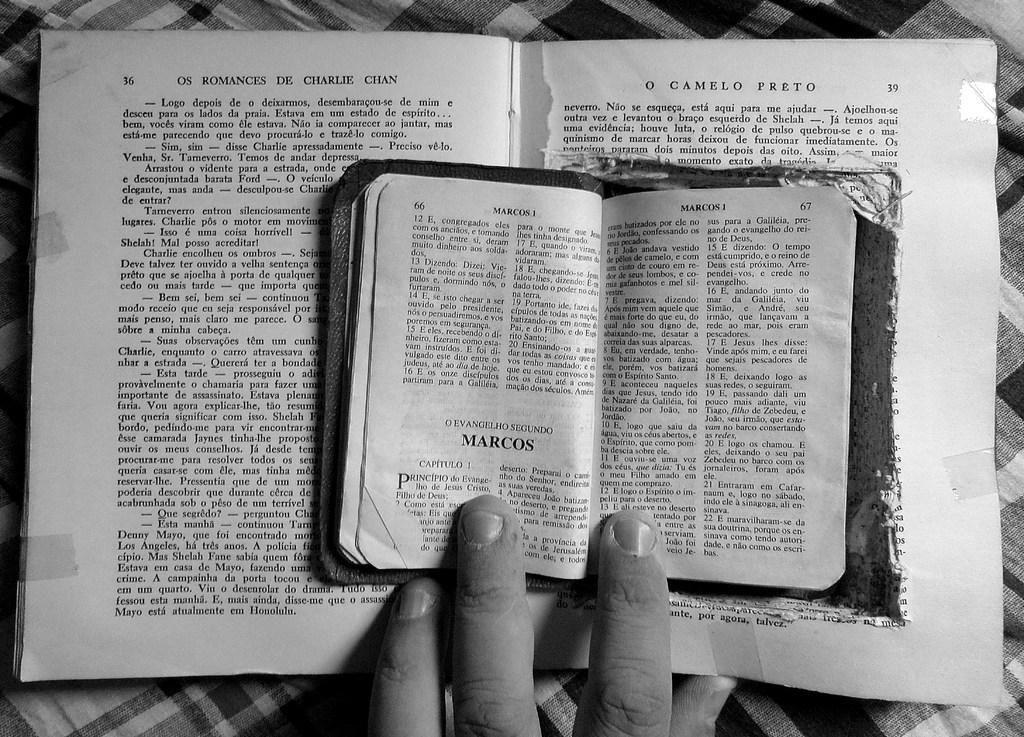In one or two sentences, can you explain what this image depicts? This picture shows couple of books on the table and we see a human hand. 